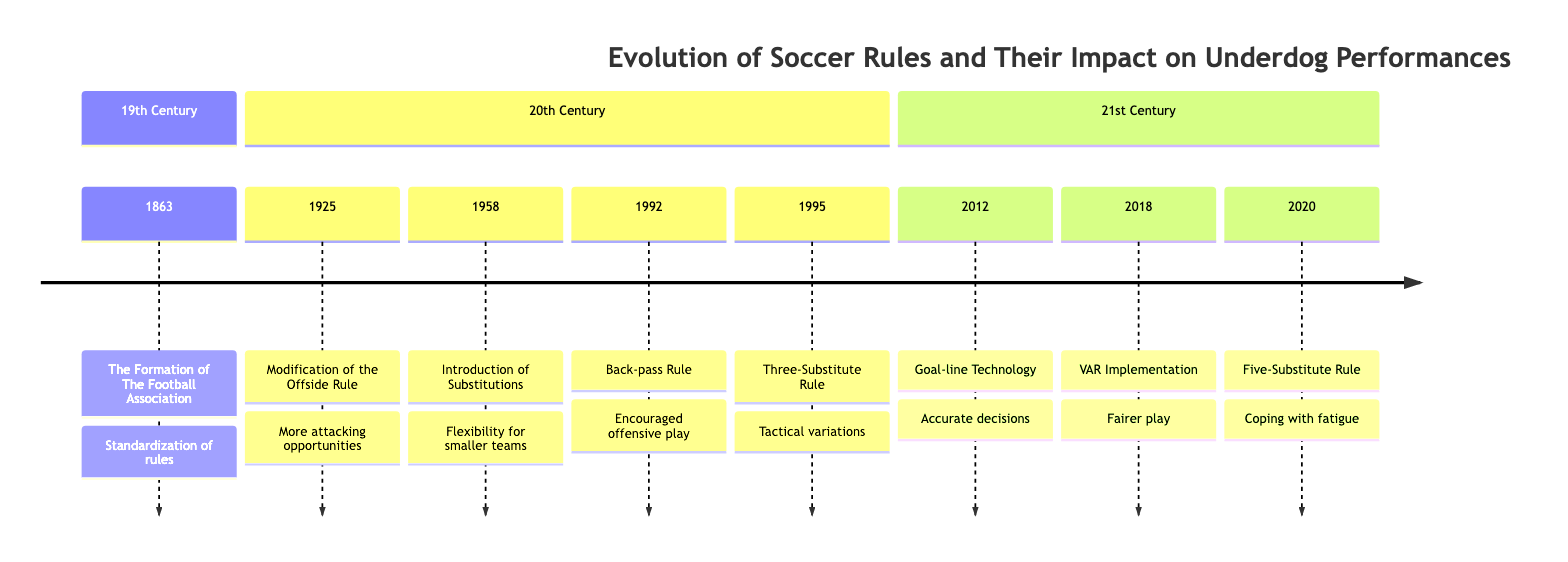What year was the Football Association formed? The timeline indicates that the Football Association was formed in 1863. This is clearly marked as the first event in the diagram.
Answer: 1863 How many key events are listed in the timeline? By counting the events in the timeline, we see there are a total of eight significant changes in soccer rules listed.
Answer: 8 Which rule was introduced in 1925? According to the timeline, the event listed for 1925 is the modification of the offside rule, which aimed to open up more space for attacking plays.
Answer: Modification of the Offside Rule What was the impact of the goal-line technology introduced in 2012? The timeline states that goal-line technology was implemented to ensure accurate decisions on goal-line clearances, which reduces human error and supports fair play for all teams.
Answer: Accurate decisions Which event allowed for five substitutions and when did this happen? The timeline indicates that the five-substitute rule was introduced during the COVID-19 pandemic in 2020, specifically to help teams manage player fatigue effectively.
Answer: 2020 What change occurred regarding substitutions in 1958? The timeline shows that in 1958, substitutions for injured players were permitted during the World Cup, allowing teams more flexibility in managing their players.
Answer: Introduction of Substitutions for Injured Players How did the back-pass rule benefit underdog teams specifically? The timeline describes that the back-pass rule, introduced in 1992, encouraged offensive strategies, allowing underdog teams to press higher up the pitch and create scoring opportunities.
Answer: Encouraged offensive play What major technology was implemented in 2018, and its purpose? In 2018, the VAR (Video Assistant Referee) was implemented, which aimed to reduce referee errors through video reviews for key decisions. This was intended to support fairer play.
Answer: VAR Implementation 